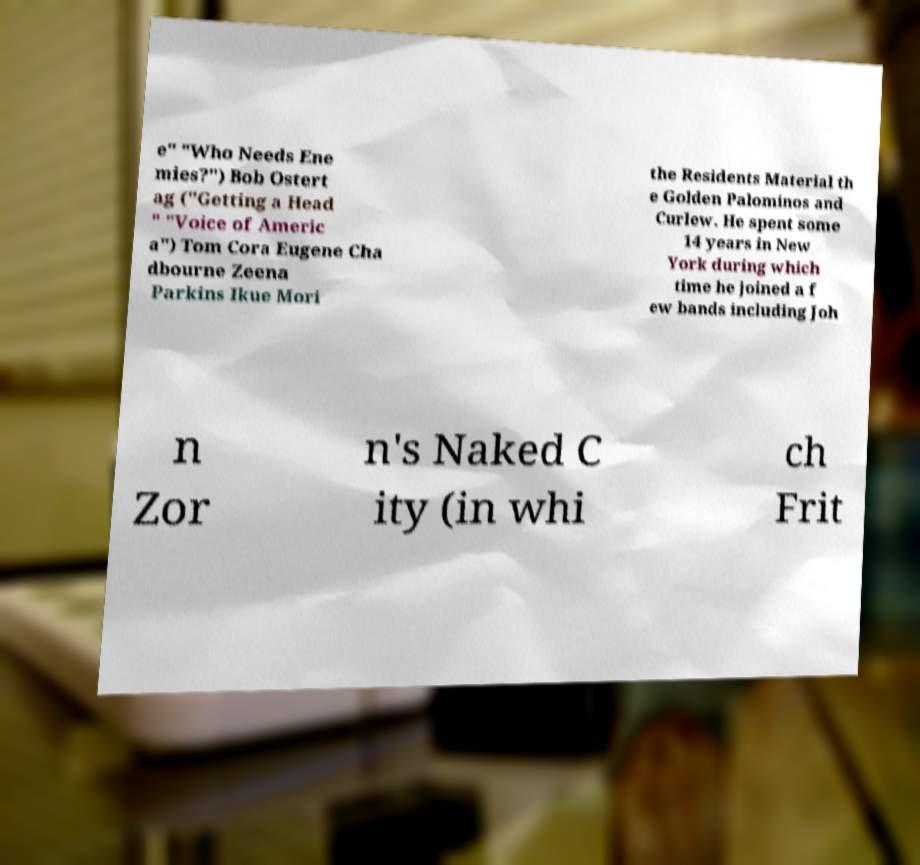Can you accurately transcribe the text from the provided image for me? e" "Who Needs Ene mies?") Bob Ostert ag ("Getting a Head " "Voice of Americ a") Tom Cora Eugene Cha dbourne Zeena Parkins Ikue Mori the Residents Material th e Golden Palominos and Curlew. He spent some 14 years in New York during which time he joined a f ew bands including Joh n Zor n's Naked C ity (in whi ch Frit 